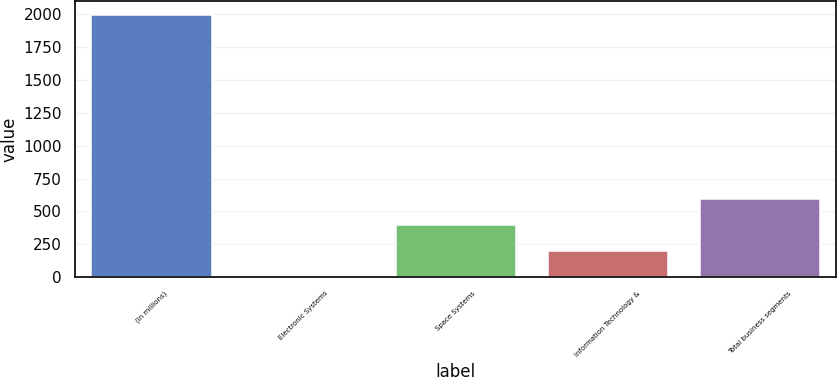<chart> <loc_0><loc_0><loc_500><loc_500><bar_chart><fcel>(In millions)<fcel>Electronic Systems<fcel>Space Systems<fcel>Information Technology &<fcel>Total business segments<nl><fcel>2005<fcel>4<fcel>404.2<fcel>204.1<fcel>604.3<nl></chart> 